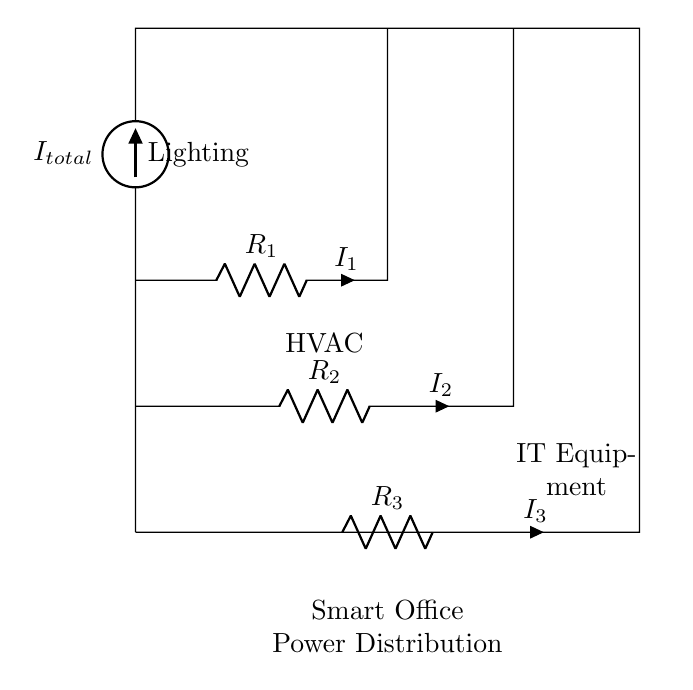What is the total current supplied in the circuit? The total current is represented by the current source labeled as I_total at the top of the circuit. It flows into the circuit.
Answer: I_total What are the components used in this circuit? The components include resistors R_1, R_2, and R_3, which are connected in parallel, and a current source I_total at the top.
Answer: Resistors and current source What is the current through R_1? The current through R_1 is indicated by the label I_1 next to the resistor itself, showing how much current flows through it specifically.
Answer: I_1 How many branches are there in the circuit? The circuit diagram has three branches, corresponding to resistors R_1, R_2, and R_3 running parallel to each other.
Answer: Three Which component is responsible for powering the lighting? The lighting is powered through the branch connected to the resistor R_1, where I_1 is indicated.
Answer: R_1 If the total current is 10A, what is the current through R_2 if R_2 is known to have lower resistance than R_1 and R_3? To find the current through R_2, consider that it will draw more current due to its lower resistance compared to others in parallel. Using the current divider formula, the distribution can be inferred but requires specific resistor values to calculate. Given no resistor values, a specific current for R_2 cannot be determined, only that it is greater than I_1 and I_3.
Answer: Greater than I_1 and I_3 What function does a current divider serve in this circuit? A current divider distributes the total incoming current among the branches based on their resistance values, allowing for specific power management in each connected device or load.
Answer: Distributes current 